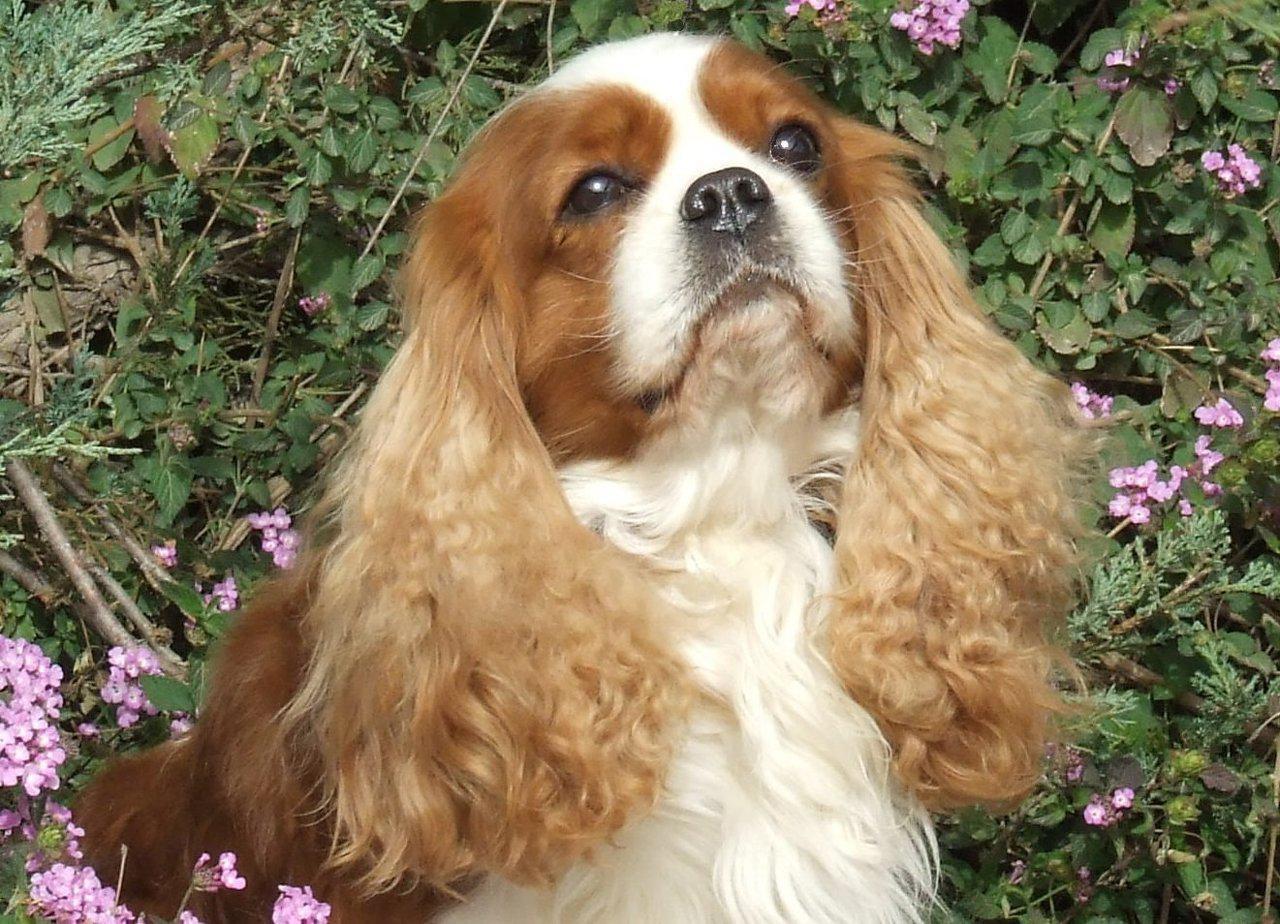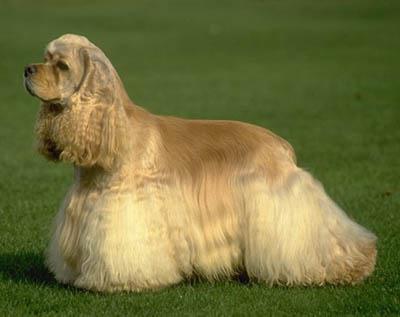The first image is the image on the left, the second image is the image on the right. Considering the images on both sides, is "Right image shows a solid colored golden spaniel standing in profile on grass." valid? Answer yes or no. Yes. 